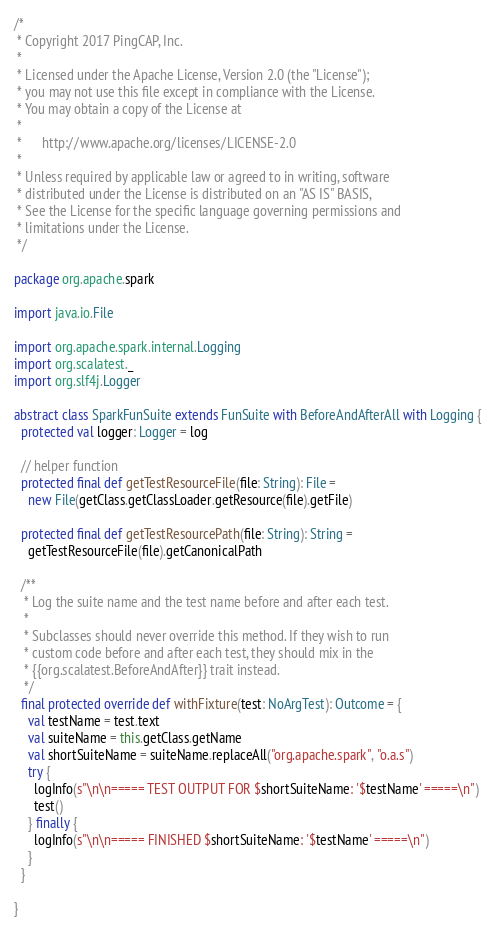<code> <loc_0><loc_0><loc_500><loc_500><_Scala_>/*
 * Copyright 2017 PingCAP, Inc.
 *
 * Licensed under the Apache License, Version 2.0 (the "License");
 * you may not use this file except in compliance with the License.
 * You may obtain a copy of the License at
 *
 *      http://www.apache.org/licenses/LICENSE-2.0
 *
 * Unless required by applicable law or agreed to in writing, software
 * distributed under the License is distributed on an "AS IS" BASIS,
 * See the License for the specific language governing permissions and
 * limitations under the License.
 */

package org.apache.spark

import java.io.File

import org.apache.spark.internal.Logging
import org.scalatest._
import org.slf4j.Logger

abstract class SparkFunSuite extends FunSuite with BeforeAndAfterAll with Logging {
  protected val logger: Logger = log

  // helper function
  protected final def getTestResourceFile(file: String): File =
    new File(getClass.getClassLoader.getResource(file).getFile)

  protected final def getTestResourcePath(file: String): String =
    getTestResourceFile(file).getCanonicalPath

  /**
   * Log the suite name and the test name before and after each test.
   *
   * Subclasses should never override this method. If they wish to run
   * custom code before and after each test, they should mix in the
   * {{org.scalatest.BeforeAndAfter}} trait instead.
   */
  final protected override def withFixture(test: NoArgTest): Outcome = {
    val testName = test.text
    val suiteName = this.getClass.getName
    val shortSuiteName = suiteName.replaceAll("org.apache.spark", "o.a.s")
    try {
      logInfo(s"\n\n===== TEST OUTPUT FOR $shortSuiteName: '$testName' =====\n")
      test()
    } finally {
      logInfo(s"\n\n===== FINISHED $shortSuiteName: '$testName' =====\n")
    }
  }

}
</code> 